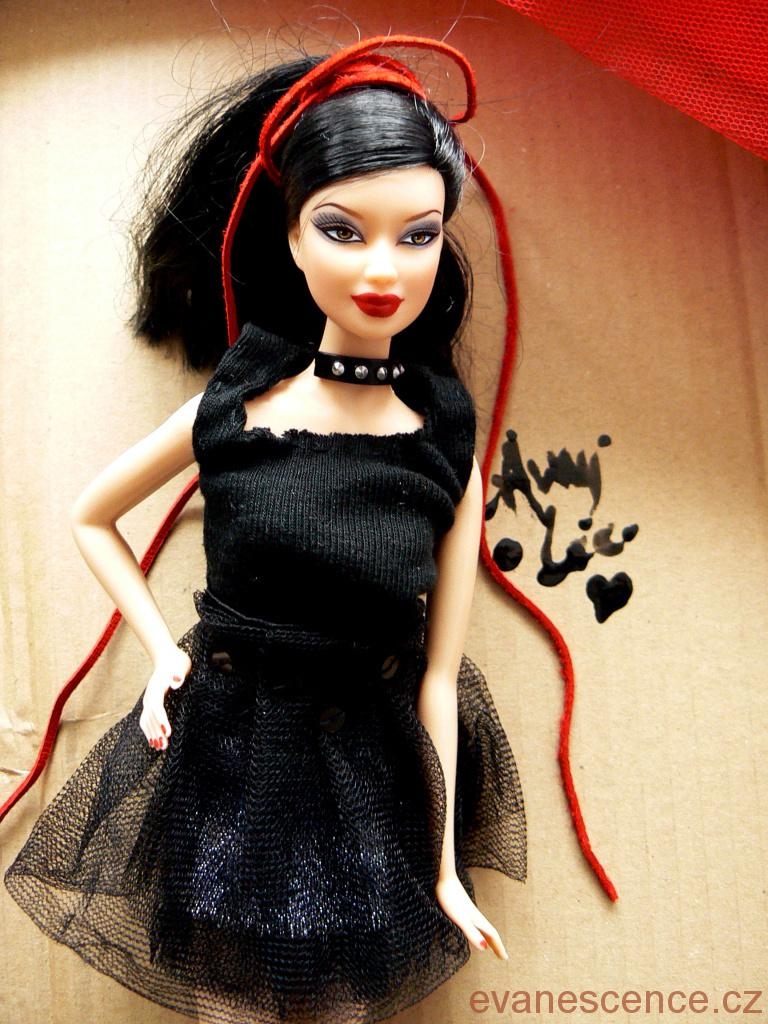What is the main subject in the center of the image? There is a doll in the center of the image. What can be seen in the background of the image? There are boxes in the background of the image. What is written or displayed at the bottom of the image? There is text at the bottom of the image. What type of jewel is the doll wearing in the image? There is no mention of a jewel or any jewelry on the doll in the provided facts, so we cannot determine if the doll is wearing a jewel in the image. 